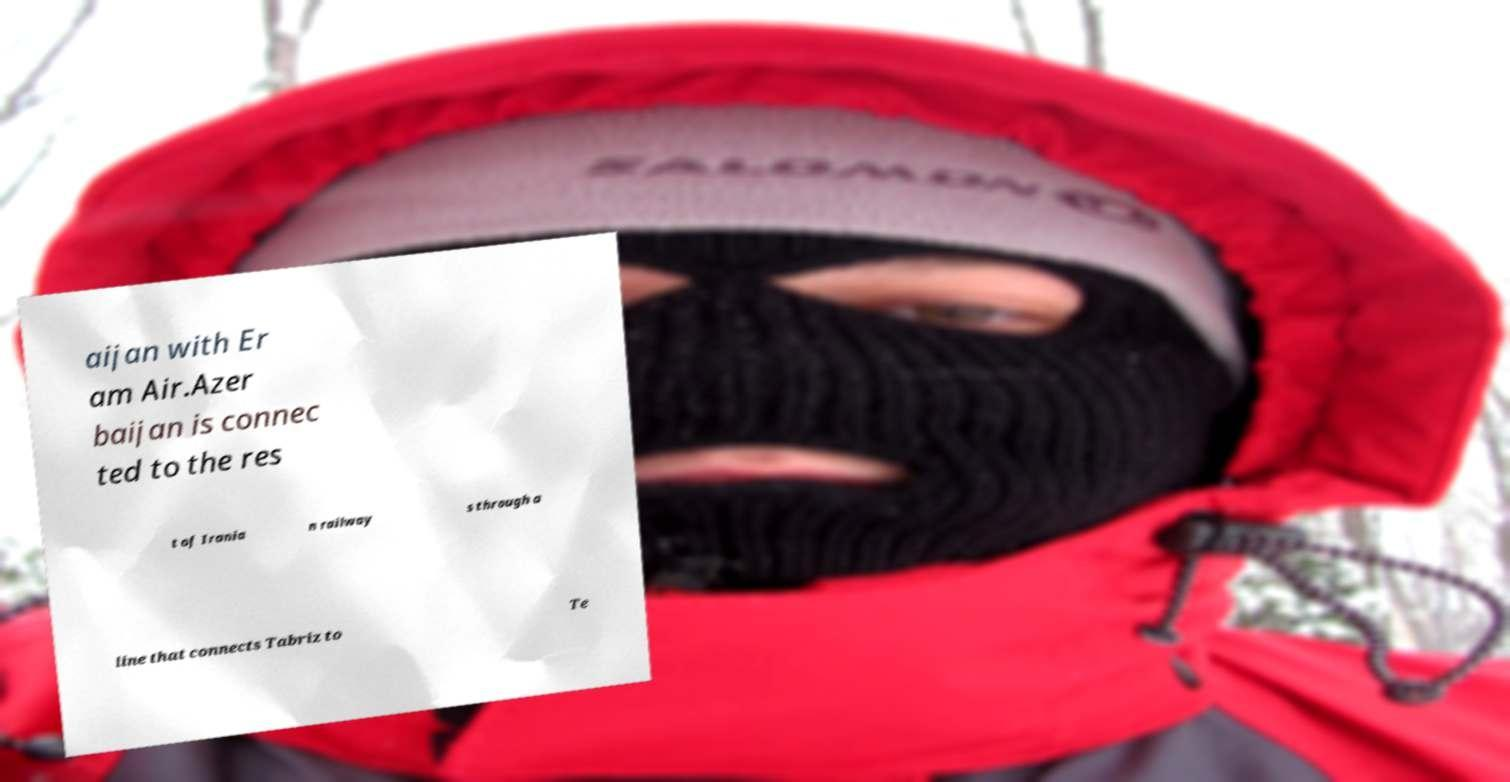Could you extract and type out the text from this image? aijan with Er am Air.Azer baijan is connec ted to the res t of Irania n railway s through a line that connects Tabriz to Te 